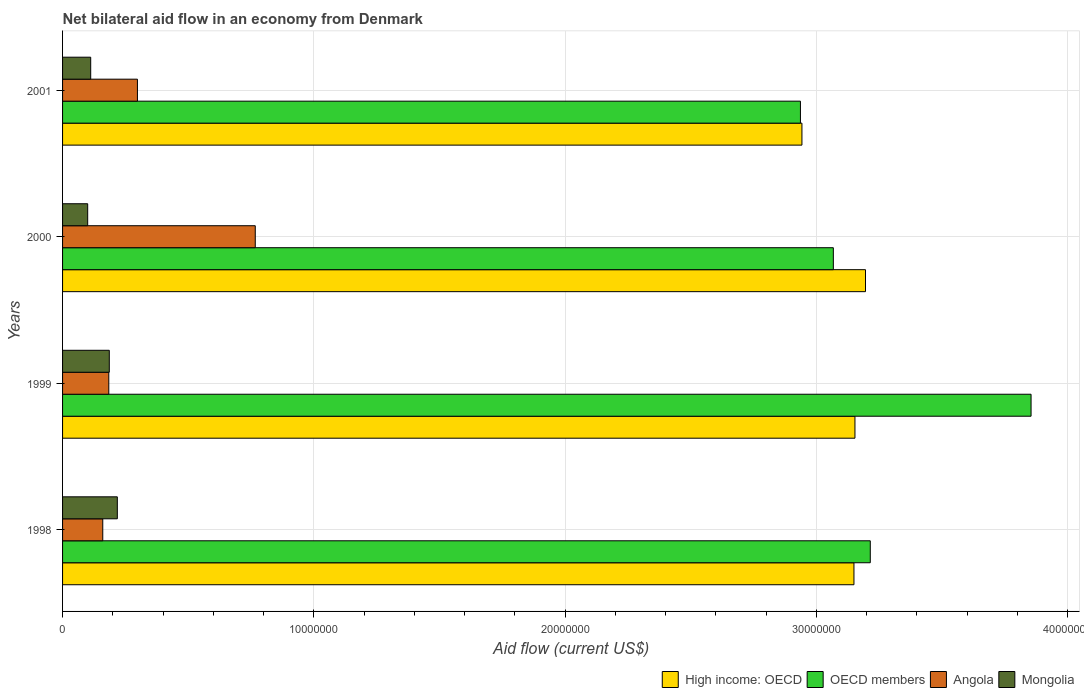How many different coloured bars are there?
Give a very brief answer. 4. How many groups of bars are there?
Keep it short and to the point. 4. Are the number of bars per tick equal to the number of legend labels?
Offer a terse response. Yes. Are the number of bars on each tick of the Y-axis equal?
Your answer should be very brief. Yes. How many bars are there on the 3rd tick from the top?
Keep it short and to the point. 4. What is the label of the 3rd group of bars from the top?
Give a very brief answer. 1999. What is the net bilateral aid flow in OECD members in 2001?
Give a very brief answer. 2.94e+07. Across all years, what is the maximum net bilateral aid flow in OECD members?
Your answer should be compact. 3.86e+07. Across all years, what is the minimum net bilateral aid flow in Angola?
Ensure brevity in your answer.  1.60e+06. In which year was the net bilateral aid flow in Angola minimum?
Offer a terse response. 1998. What is the total net bilateral aid flow in Mongolia in the graph?
Your answer should be compact. 6.16e+06. What is the difference between the net bilateral aid flow in High income: OECD in 1998 and that in 2000?
Provide a short and direct response. -4.60e+05. What is the difference between the net bilateral aid flow in OECD members in 1998 and the net bilateral aid flow in High income: OECD in 1999?
Provide a succinct answer. 6.10e+05. What is the average net bilateral aid flow in Mongolia per year?
Your response must be concise. 1.54e+06. In the year 1999, what is the difference between the net bilateral aid flow in High income: OECD and net bilateral aid flow in OECD members?
Offer a terse response. -7.01e+06. In how many years, is the net bilateral aid flow in Angola greater than 10000000 US$?
Make the answer very short. 0. What is the ratio of the net bilateral aid flow in High income: OECD in 1998 to that in 2001?
Provide a short and direct response. 1.07. Is the net bilateral aid flow in OECD members in 1999 less than that in 2000?
Keep it short and to the point. No. What is the difference between the highest and the second highest net bilateral aid flow in Mongolia?
Your answer should be very brief. 3.20e+05. What is the difference between the highest and the lowest net bilateral aid flow in Angola?
Provide a succinct answer. 6.07e+06. In how many years, is the net bilateral aid flow in Angola greater than the average net bilateral aid flow in Angola taken over all years?
Make the answer very short. 1. Is the sum of the net bilateral aid flow in OECD members in 1999 and 2001 greater than the maximum net bilateral aid flow in Mongolia across all years?
Offer a terse response. Yes. What does the 1st bar from the top in 2001 represents?
Your answer should be compact. Mongolia. What does the 2nd bar from the bottom in 2000 represents?
Offer a very short reply. OECD members. Is it the case that in every year, the sum of the net bilateral aid flow in OECD members and net bilateral aid flow in High income: OECD is greater than the net bilateral aid flow in Angola?
Keep it short and to the point. Yes. Does the graph contain any zero values?
Your answer should be very brief. No. Does the graph contain grids?
Give a very brief answer. Yes. How many legend labels are there?
Offer a very short reply. 4. What is the title of the graph?
Provide a short and direct response. Net bilateral aid flow in an economy from Denmark. What is the label or title of the X-axis?
Provide a short and direct response. Aid flow (current US$). What is the label or title of the Y-axis?
Offer a terse response. Years. What is the Aid flow (current US$) in High income: OECD in 1998?
Your answer should be compact. 3.15e+07. What is the Aid flow (current US$) in OECD members in 1998?
Your answer should be very brief. 3.22e+07. What is the Aid flow (current US$) of Angola in 1998?
Your answer should be compact. 1.60e+06. What is the Aid flow (current US$) in Mongolia in 1998?
Offer a very short reply. 2.18e+06. What is the Aid flow (current US$) of High income: OECD in 1999?
Provide a short and direct response. 3.15e+07. What is the Aid flow (current US$) of OECD members in 1999?
Give a very brief answer. 3.86e+07. What is the Aid flow (current US$) of Angola in 1999?
Your answer should be very brief. 1.84e+06. What is the Aid flow (current US$) of Mongolia in 1999?
Your response must be concise. 1.86e+06. What is the Aid flow (current US$) of High income: OECD in 2000?
Offer a very short reply. 3.20e+07. What is the Aid flow (current US$) in OECD members in 2000?
Give a very brief answer. 3.07e+07. What is the Aid flow (current US$) of Angola in 2000?
Offer a very short reply. 7.67e+06. What is the Aid flow (current US$) of High income: OECD in 2001?
Your answer should be compact. 2.94e+07. What is the Aid flow (current US$) in OECD members in 2001?
Offer a terse response. 2.94e+07. What is the Aid flow (current US$) of Angola in 2001?
Your response must be concise. 2.98e+06. What is the Aid flow (current US$) in Mongolia in 2001?
Make the answer very short. 1.12e+06. Across all years, what is the maximum Aid flow (current US$) in High income: OECD?
Your answer should be very brief. 3.20e+07. Across all years, what is the maximum Aid flow (current US$) in OECD members?
Your answer should be compact. 3.86e+07. Across all years, what is the maximum Aid flow (current US$) in Angola?
Make the answer very short. 7.67e+06. Across all years, what is the maximum Aid flow (current US$) of Mongolia?
Ensure brevity in your answer.  2.18e+06. Across all years, what is the minimum Aid flow (current US$) in High income: OECD?
Keep it short and to the point. 2.94e+07. Across all years, what is the minimum Aid flow (current US$) in OECD members?
Ensure brevity in your answer.  2.94e+07. Across all years, what is the minimum Aid flow (current US$) in Angola?
Offer a terse response. 1.60e+06. Across all years, what is the minimum Aid flow (current US$) in Mongolia?
Your answer should be compact. 1.00e+06. What is the total Aid flow (current US$) of High income: OECD in the graph?
Offer a terse response. 1.24e+08. What is the total Aid flow (current US$) in OECD members in the graph?
Offer a very short reply. 1.31e+08. What is the total Aid flow (current US$) of Angola in the graph?
Keep it short and to the point. 1.41e+07. What is the total Aid flow (current US$) of Mongolia in the graph?
Ensure brevity in your answer.  6.16e+06. What is the difference between the Aid flow (current US$) in OECD members in 1998 and that in 1999?
Offer a terse response. -6.40e+06. What is the difference between the Aid flow (current US$) in Angola in 1998 and that in 1999?
Make the answer very short. -2.40e+05. What is the difference between the Aid flow (current US$) in Mongolia in 1998 and that in 1999?
Your response must be concise. 3.20e+05. What is the difference between the Aid flow (current US$) in High income: OECD in 1998 and that in 2000?
Provide a short and direct response. -4.60e+05. What is the difference between the Aid flow (current US$) in OECD members in 1998 and that in 2000?
Ensure brevity in your answer.  1.47e+06. What is the difference between the Aid flow (current US$) in Angola in 1998 and that in 2000?
Offer a terse response. -6.07e+06. What is the difference between the Aid flow (current US$) in Mongolia in 1998 and that in 2000?
Provide a short and direct response. 1.18e+06. What is the difference between the Aid flow (current US$) of High income: OECD in 1998 and that in 2001?
Provide a succinct answer. 2.07e+06. What is the difference between the Aid flow (current US$) of OECD members in 1998 and that in 2001?
Make the answer very short. 2.78e+06. What is the difference between the Aid flow (current US$) in Angola in 1998 and that in 2001?
Your answer should be very brief. -1.38e+06. What is the difference between the Aid flow (current US$) in Mongolia in 1998 and that in 2001?
Give a very brief answer. 1.06e+06. What is the difference between the Aid flow (current US$) of High income: OECD in 1999 and that in 2000?
Your answer should be compact. -4.20e+05. What is the difference between the Aid flow (current US$) in OECD members in 1999 and that in 2000?
Offer a very short reply. 7.87e+06. What is the difference between the Aid flow (current US$) of Angola in 1999 and that in 2000?
Offer a terse response. -5.83e+06. What is the difference between the Aid flow (current US$) of Mongolia in 1999 and that in 2000?
Your answer should be very brief. 8.60e+05. What is the difference between the Aid flow (current US$) in High income: OECD in 1999 and that in 2001?
Your response must be concise. 2.11e+06. What is the difference between the Aid flow (current US$) of OECD members in 1999 and that in 2001?
Give a very brief answer. 9.18e+06. What is the difference between the Aid flow (current US$) of Angola in 1999 and that in 2001?
Your answer should be very brief. -1.14e+06. What is the difference between the Aid flow (current US$) in Mongolia in 1999 and that in 2001?
Give a very brief answer. 7.40e+05. What is the difference between the Aid flow (current US$) in High income: OECD in 2000 and that in 2001?
Offer a very short reply. 2.53e+06. What is the difference between the Aid flow (current US$) in OECD members in 2000 and that in 2001?
Your response must be concise. 1.31e+06. What is the difference between the Aid flow (current US$) in Angola in 2000 and that in 2001?
Your response must be concise. 4.69e+06. What is the difference between the Aid flow (current US$) of Mongolia in 2000 and that in 2001?
Keep it short and to the point. -1.20e+05. What is the difference between the Aid flow (current US$) of High income: OECD in 1998 and the Aid flow (current US$) of OECD members in 1999?
Make the answer very short. -7.05e+06. What is the difference between the Aid flow (current US$) in High income: OECD in 1998 and the Aid flow (current US$) in Angola in 1999?
Give a very brief answer. 2.97e+07. What is the difference between the Aid flow (current US$) in High income: OECD in 1998 and the Aid flow (current US$) in Mongolia in 1999?
Your answer should be very brief. 2.96e+07. What is the difference between the Aid flow (current US$) in OECD members in 1998 and the Aid flow (current US$) in Angola in 1999?
Keep it short and to the point. 3.03e+07. What is the difference between the Aid flow (current US$) in OECD members in 1998 and the Aid flow (current US$) in Mongolia in 1999?
Provide a short and direct response. 3.03e+07. What is the difference between the Aid flow (current US$) of High income: OECD in 1998 and the Aid flow (current US$) of OECD members in 2000?
Your response must be concise. 8.20e+05. What is the difference between the Aid flow (current US$) in High income: OECD in 1998 and the Aid flow (current US$) in Angola in 2000?
Your answer should be very brief. 2.38e+07. What is the difference between the Aid flow (current US$) in High income: OECD in 1998 and the Aid flow (current US$) in Mongolia in 2000?
Offer a very short reply. 3.05e+07. What is the difference between the Aid flow (current US$) in OECD members in 1998 and the Aid flow (current US$) in Angola in 2000?
Ensure brevity in your answer.  2.45e+07. What is the difference between the Aid flow (current US$) of OECD members in 1998 and the Aid flow (current US$) of Mongolia in 2000?
Your response must be concise. 3.12e+07. What is the difference between the Aid flow (current US$) in Angola in 1998 and the Aid flow (current US$) in Mongolia in 2000?
Your answer should be compact. 6.00e+05. What is the difference between the Aid flow (current US$) in High income: OECD in 1998 and the Aid flow (current US$) in OECD members in 2001?
Your answer should be compact. 2.13e+06. What is the difference between the Aid flow (current US$) of High income: OECD in 1998 and the Aid flow (current US$) of Angola in 2001?
Your answer should be compact. 2.85e+07. What is the difference between the Aid flow (current US$) in High income: OECD in 1998 and the Aid flow (current US$) in Mongolia in 2001?
Your answer should be compact. 3.04e+07. What is the difference between the Aid flow (current US$) of OECD members in 1998 and the Aid flow (current US$) of Angola in 2001?
Keep it short and to the point. 2.92e+07. What is the difference between the Aid flow (current US$) in OECD members in 1998 and the Aid flow (current US$) in Mongolia in 2001?
Keep it short and to the point. 3.10e+07. What is the difference between the Aid flow (current US$) in Angola in 1998 and the Aid flow (current US$) in Mongolia in 2001?
Offer a terse response. 4.80e+05. What is the difference between the Aid flow (current US$) of High income: OECD in 1999 and the Aid flow (current US$) of OECD members in 2000?
Your answer should be very brief. 8.60e+05. What is the difference between the Aid flow (current US$) of High income: OECD in 1999 and the Aid flow (current US$) of Angola in 2000?
Your answer should be very brief. 2.39e+07. What is the difference between the Aid flow (current US$) of High income: OECD in 1999 and the Aid flow (current US$) of Mongolia in 2000?
Give a very brief answer. 3.05e+07. What is the difference between the Aid flow (current US$) of OECD members in 1999 and the Aid flow (current US$) of Angola in 2000?
Provide a succinct answer. 3.09e+07. What is the difference between the Aid flow (current US$) of OECD members in 1999 and the Aid flow (current US$) of Mongolia in 2000?
Your answer should be compact. 3.76e+07. What is the difference between the Aid flow (current US$) of Angola in 1999 and the Aid flow (current US$) of Mongolia in 2000?
Your response must be concise. 8.40e+05. What is the difference between the Aid flow (current US$) in High income: OECD in 1999 and the Aid flow (current US$) in OECD members in 2001?
Make the answer very short. 2.17e+06. What is the difference between the Aid flow (current US$) of High income: OECD in 1999 and the Aid flow (current US$) of Angola in 2001?
Provide a short and direct response. 2.86e+07. What is the difference between the Aid flow (current US$) in High income: OECD in 1999 and the Aid flow (current US$) in Mongolia in 2001?
Keep it short and to the point. 3.04e+07. What is the difference between the Aid flow (current US$) in OECD members in 1999 and the Aid flow (current US$) in Angola in 2001?
Keep it short and to the point. 3.56e+07. What is the difference between the Aid flow (current US$) of OECD members in 1999 and the Aid flow (current US$) of Mongolia in 2001?
Your answer should be compact. 3.74e+07. What is the difference between the Aid flow (current US$) in Angola in 1999 and the Aid flow (current US$) in Mongolia in 2001?
Your answer should be compact. 7.20e+05. What is the difference between the Aid flow (current US$) in High income: OECD in 2000 and the Aid flow (current US$) in OECD members in 2001?
Make the answer very short. 2.59e+06. What is the difference between the Aid flow (current US$) in High income: OECD in 2000 and the Aid flow (current US$) in Angola in 2001?
Make the answer very short. 2.90e+07. What is the difference between the Aid flow (current US$) in High income: OECD in 2000 and the Aid flow (current US$) in Mongolia in 2001?
Offer a terse response. 3.08e+07. What is the difference between the Aid flow (current US$) in OECD members in 2000 and the Aid flow (current US$) in Angola in 2001?
Keep it short and to the point. 2.77e+07. What is the difference between the Aid flow (current US$) of OECD members in 2000 and the Aid flow (current US$) of Mongolia in 2001?
Offer a terse response. 2.96e+07. What is the difference between the Aid flow (current US$) in Angola in 2000 and the Aid flow (current US$) in Mongolia in 2001?
Provide a short and direct response. 6.55e+06. What is the average Aid flow (current US$) of High income: OECD per year?
Give a very brief answer. 3.11e+07. What is the average Aid flow (current US$) in OECD members per year?
Keep it short and to the point. 3.27e+07. What is the average Aid flow (current US$) of Angola per year?
Offer a very short reply. 3.52e+06. What is the average Aid flow (current US$) of Mongolia per year?
Keep it short and to the point. 1.54e+06. In the year 1998, what is the difference between the Aid flow (current US$) of High income: OECD and Aid flow (current US$) of OECD members?
Offer a terse response. -6.50e+05. In the year 1998, what is the difference between the Aid flow (current US$) of High income: OECD and Aid flow (current US$) of Angola?
Keep it short and to the point. 2.99e+07. In the year 1998, what is the difference between the Aid flow (current US$) in High income: OECD and Aid flow (current US$) in Mongolia?
Provide a succinct answer. 2.93e+07. In the year 1998, what is the difference between the Aid flow (current US$) of OECD members and Aid flow (current US$) of Angola?
Provide a succinct answer. 3.06e+07. In the year 1998, what is the difference between the Aid flow (current US$) of OECD members and Aid flow (current US$) of Mongolia?
Keep it short and to the point. 3.00e+07. In the year 1998, what is the difference between the Aid flow (current US$) in Angola and Aid flow (current US$) in Mongolia?
Your answer should be compact. -5.80e+05. In the year 1999, what is the difference between the Aid flow (current US$) of High income: OECD and Aid flow (current US$) of OECD members?
Give a very brief answer. -7.01e+06. In the year 1999, what is the difference between the Aid flow (current US$) in High income: OECD and Aid flow (current US$) in Angola?
Provide a succinct answer. 2.97e+07. In the year 1999, what is the difference between the Aid flow (current US$) in High income: OECD and Aid flow (current US$) in Mongolia?
Your response must be concise. 2.97e+07. In the year 1999, what is the difference between the Aid flow (current US$) in OECD members and Aid flow (current US$) in Angola?
Make the answer very short. 3.67e+07. In the year 1999, what is the difference between the Aid flow (current US$) of OECD members and Aid flow (current US$) of Mongolia?
Your answer should be compact. 3.67e+07. In the year 1999, what is the difference between the Aid flow (current US$) of Angola and Aid flow (current US$) of Mongolia?
Your response must be concise. -2.00e+04. In the year 2000, what is the difference between the Aid flow (current US$) of High income: OECD and Aid flow (current US$) of OECD members?
Your response must be concise. 1.28e+06. In the year 2000, what is the difference between the Aid flow (current US$) of High income: OECD and Aid flow (current US$) of Angola?
Give a very brief answer. 2.43e+07. In the year 2000, what is the difference between the Aid flow (current US$) of High income: OECD and Aid flow (current US$) of Mongolia?
Offer a terse response. 3.10e+07. In the year 2000, what is the difference between the Aid flow (current US$) in OECD members and Aid flow (current US$) in Angola?
Give a very brief answer. 2.30e+07. In the year 2000, what is the difference between the Aid flow (current US$) in OECD members and Aid flow (current US$) in Mongolia?
Keep it short and to the point. 2.97e+07. In the year 2000, what is the difference between the Aid flow (current US$) in Angola and Aid flow (current US$) in Mongolia?
Provide a short and direct response. 6.67e+06. In the year 2001, what is the difference between the Aid flow (current US$) of High income: OECD and Aid flow (current US$) of OECD members?
Offer a very short reply. 6.00e+04. In the year 2001, what is the difference between the Aid flow (current US$) in High income: OECD and Aid flow (current US$) in Angola?
Your response must be concise. 2.64e+07. In the year 2001, what is the difference between the Aid flow (current US$) of High income: OECD and Aid flow (current US$) of Mongolia?
Your response must be concise. 2.83e+07. In the year 2001, what is the difference between the Aid flow (current US$) in OECD members and Aid flow (current US$) in Angola?
Ensure brevity in your answer.  2.64e+07. In the year 2001, what is the difference between the Aid flow (current US$) of OECD members and Aid flow (current US$) of Mongolia?
Your answer should be compact. 2.82e+07. In the year 2001, what is the difference between the Aid flow (current US$) of Angola and Aid flow (current US$) of Mongolia?
Your answer should be very brief. 1.86e+06. What is the ratio of the Aid flow (current US$) in High income: OECD in 1998 to that in 1999?
Provide a succinct answer. 1. What is the ratio of the Aid flow (current US$) of OECD members in 1998 to that in 1999?
Your answer should be very brief. 0.83. What is the ratio of the Aid flow (current US$) of Angola in 1998 to that in 1999?
Keep it short and to the point. 0.87. What is the ratio of the Aid flow (current US$) in Mongolia in 1998 to that in 1999?
Provide a short and direct response. 1.17. What is the ratio of the Aid flow (current US$) in High income: OECD in 1998 to that in 2000?
Ensure brevity in your answer.  0.99. What is the ratio of the Aid flow (current US$) of OECD members in 1998 to that in 2000?
Offer a terse response. 1.05. What is the ratio of the Aid flow (current US$) in Angola in 1998 to that in 2000?
Your response must be concise. 0.21. What is the ratio of the Aid flow (current US$) in Mongolia in 1998 to that in 2000?
Ensure brevity in your answer.  2.18. What is the ratio of the Aid flow (current US$) of High income: OECD in 1998 to that in 2001?
Provide a short and direct response. 1.07. What is the ratio of the Aid flow (current US$) in OECD members in 1998 to that in 2001?
Provide a succinct answer. 1.09. What is the ratio of the Aid flow (current US$) of Angola in 1998 to that in 2001?
Provide a short and direct response. 0.54. What is the ratio of the Aid flow (current US$) of Mongolia in 1998 to that in 2001?
Ensure brevity in your answer.  1.95. What is the ratio of the Aid flow (current US$) of High income: OECD in 1999 to that in 2000?
Offer a very short reply. 0.99. What is the ratio of the Aid flow (current US$) of OECD members in 1999 to that in 2000?
Your answer should be compact. 1.26. What is the ratio of the Aid flow (current US$) of Angola in 1999 to that in 2000?
Provide a succinct answer. 0.24. What is the ratio of the Aid flow (current US$) of Mongolia in 1999 to that in 2000?
Provide a succinct answer. 1.86. What is the ratio of the Aid flow (current US$) of High income: OECD in 1999 to that in 2001?
Offer a very short reply. 1.07. What is the ratio of the Aid flow (current US$) in OECD members in 1999 to that in 2001?
Provide a short and direct response. 1.31. What is the ratio of the Aid flow (current US$) in Angola in 1999 to that in 2001?
Provide a short and direct response. 0.62. What is the ratio of the Aid flow (current US$) of Mongolia in 1999 to that in 2001?
Provide a short and direct response. 1.66. What is the ratio of the Aid flow (current US$) of High income: OECD in 2000 to that in 2001?
Offer a terse response. 1.09. What is the ratio of the Aid flow (current US$) of OECD members in 2000 to that in 2001?
Offer a terse response. 1.04. What is the ratio of the Aid flow (current US$) in Angola in 2000 to that in 2001?
Make the answer very short. 2.57. What is the ratio of the Aid flow (current US$) of Mongolia in 2000 to that in 2001?
Ensure brevity in your answer.  0.89. What is the difference between the highest and the second highest Aid flow (current US$) in OECD members?
Your answer should be compact. 6.40e+06. What is the difference between the highest and the second highest Aid flow (current US$) of Angola?
Your answer should be very brief. 4.69e+06. What is the difference between the highest and the lowest Aid flow (current US$) of High income: OECD?
Your answer should be very brief. 2.53e+06. What is the difference between the highest and the lowest Aid flow (current US$) of OECD members?
Make the answer very short. 9.18e+06. What is the difference between the highest and the lowest Aid flow (current US$) of Angola?
Offer a terse response. 6.07e+06. What is the difference between the highest and the lowest Aid flow (current US$) of Mongolia?
Give a very brief answer. 1.18e+06. 